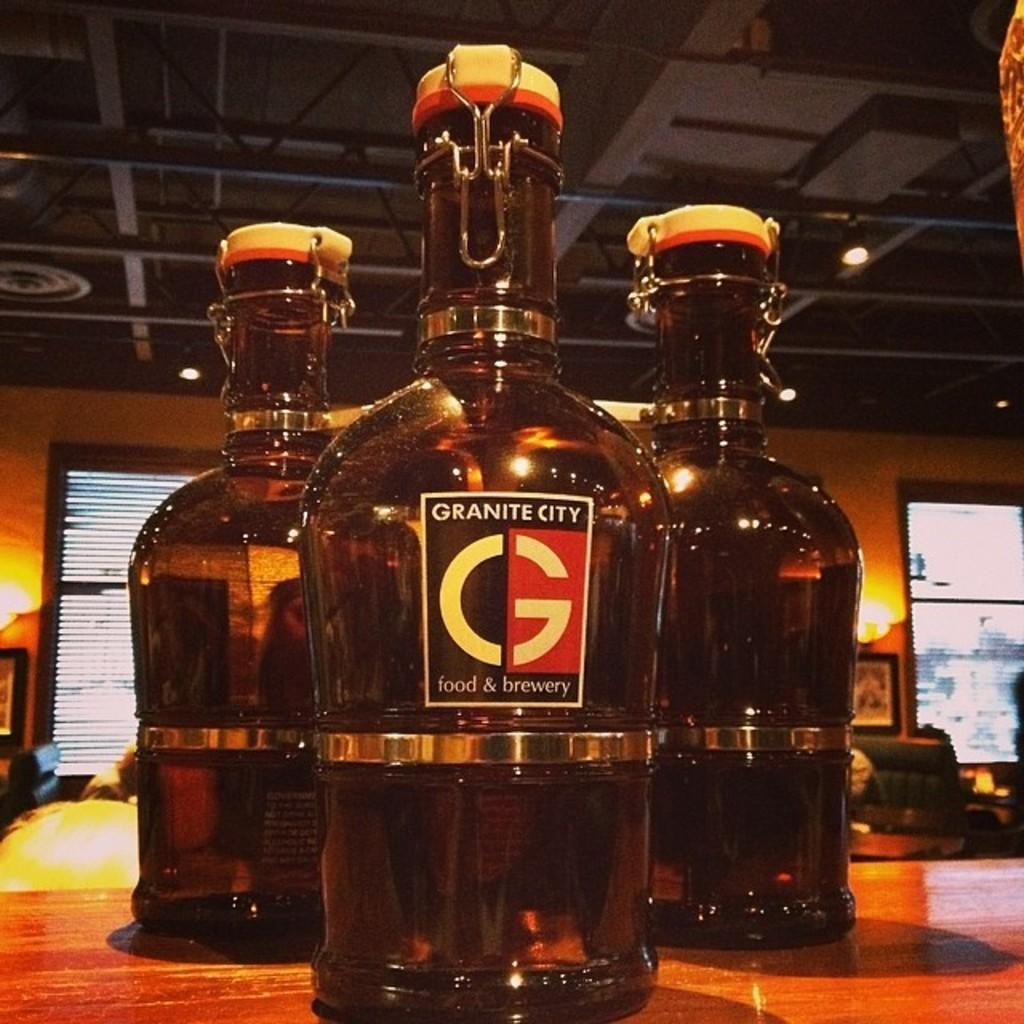Provide a one-sentence caption for the provided image. A jug of Granite City sits in front of two other jugs. 